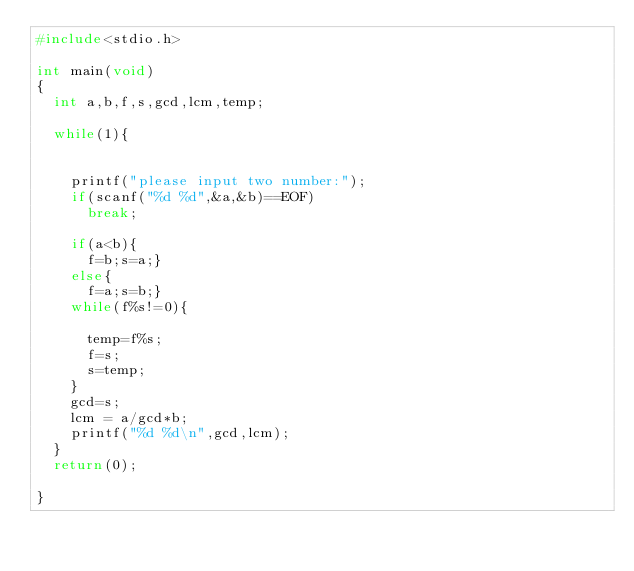Convert code to text. <code><loc_0><loc_0><loc_500><loc_500><_C_>#include<stdio.h>

int main(void)
{
  int a,b,f,s,gcd,lcm,temp;
  
  while(1){
    
    
    printf("please input two number:");
    if(scanf("%d %d",&a,&b)==EOF)
      break;
  
    if(a<b){
      f=b;s=a;}
    else{
      f=a;s=b;}
    while(f%s!=0){
      
      temp=f%s;
      f=s;
      s=temp;
    }
    gcd=s;
    lcm = a/gcd*b;
    printf("%d %d\n",gcd,lcm);
  }
  return(0);

}</code> 